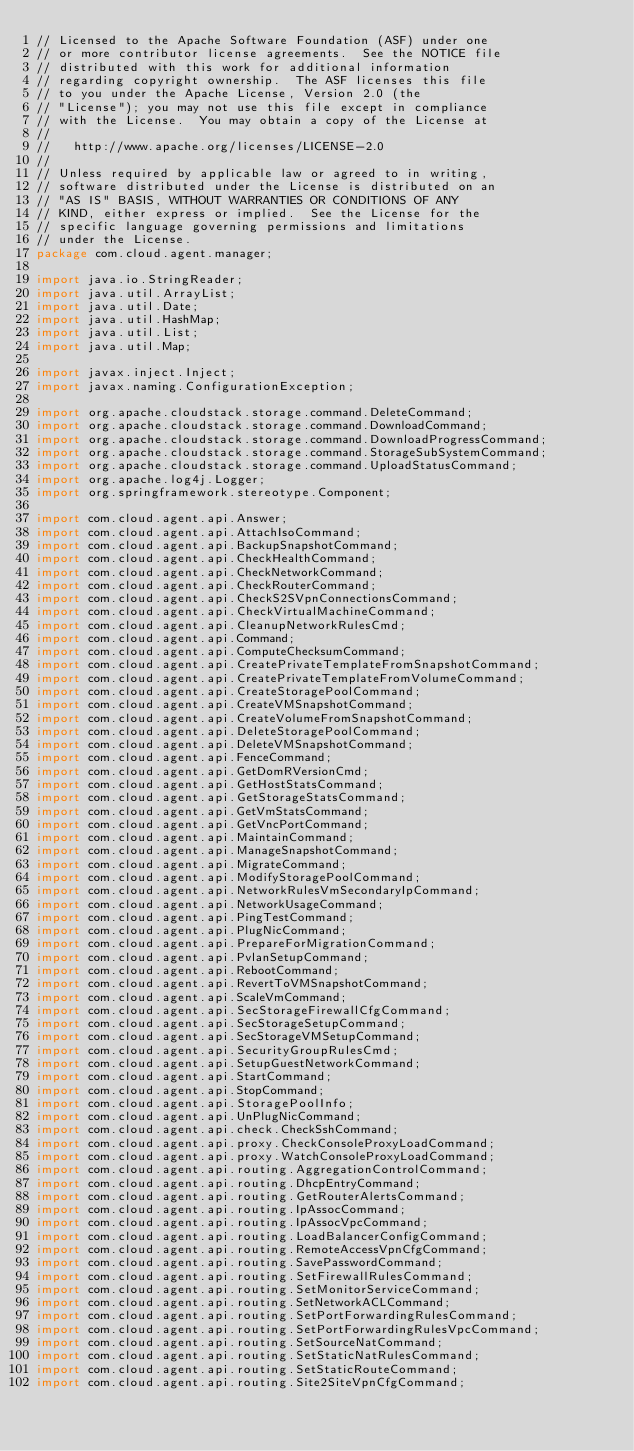<code> <loc_0><loc_0><loc_500><loc_500><_Java_>// Licensed to the Apache Software Foundation (ASF) under one
// or more contributor license agreements.  See the NOTICE file
// distributed with this work for additional information
// regarding copyright ownership.  The ASF licenses this file
// to you under the Apache License, Version 2.0 (the
// "License"); you may not use this file except in compliance
// with the License.  You may obtain a copy of the License at
//
//   http://www.apache.org/licenses/LICENSE-2.0
//
// Unless required by applicable law or agreed to in writing,
// software distributed under the License is distributed on an
// "AS IS" BASIS, WITHOUT WARRANTIES OR CONDITIONS OF ANY
// KIND, either express or implied.  See the License for the
// specific language governing permissions and limitations
// under the License.
package com.cloud.agent.manager;

import java.io.StringReader;
import java.util.ArrayList;
import java.util.Date;
import java.util.HashMap;
import java.util.List;
import java.util.Map;

import javax.inject.Inject;
import javax.naming.ConfigurationException;

import org.apache.cloudstack.storage.command.DeleteCommand;
import org.apache.cloudstack.storage.command.DownloadCommand;
import org.apache.cloudstack.storage.command.DownloadProgressCommand;
import org.apache.cloudstack.storage.command.StorageSubSystemCommand;
import org.apache.cloudstack.storage.command.UploadStatusCommand;
import org.apache.log4j.Logger;
import org.springframework.stereotype.Component;

import com.cloud.agent.api.Answer;
import com.cloud.agent.api.AttachIsoCommand;
import com.cloud.agent.api.BackupSnapshotCommand;
import com.cloud.agent.api.CheckHealthCommand;
import com.cloud.agent.api.CheckNetworkCommand;
import com.cloud.agent.api.CheckRouterCommand;
import com.cloud.agent.api.CheckS2SVpnConnectionsCommand;
import com.cloud.agent.api.CheckVirtualMachineCommand;
import com.cloud.agent.api.CleanupNetworkRulesCmd;
import com.cloud.agent.api.Command;
import com.cloud.agent.api.ComputeChecksumCommand;
import com.cloud.agent.api.CreatePrivateTemplateFromSnapshotCommand;
import com.cloud.agent.api.CreatePrivateTemplateFromVolumeCommand;
import com.cloud.agent.api.CreateStoragePoolCommand;
import com.cloud.agent.api.CreateVMSnapshotCommand;
import com.cloud.agent.api.CreateVolumeFromSnapshotCommand;
import com.cloud.agent.api.DeleteStoragePoolCommand;
import com.cloud.agent.api.DeleteVMSnapshotCommand;
import com.cloud.agent.api.FenceCommand;
import com.cloud.agent.api.GetDomRVersionCmd;
import com.cloud.agent.api.GetHostStatsCommand;
import com.cloud.agent.api.GetStorageStatsCommand;
import com.cloud.agent.api.GetVmStatsCommand;
import com.cloud.agent.api.GetVncPortCommand;
import com.cloud.agent.api.MaintainCommand;
import com.cloud.agent.api.ManageSnapshotCommand;
import com.cloud.agent.api.MigrateCommand;
import com.cloud.agent.api.ModifyStoragePoolCommand;
import com.cloud.agent.api.NetworkRulesVmSecondaryIpCommand;
import com.cloud.agent.api.NetworkUsageCommand;
import com.cloud.agent.api.PingTestCommand;
import com.cloud.agent.api.PlugNicCommand;
import com.cloud.agent.api.PrepareForMigrationCommand;
import com.cloud.agent.api.PvlanSetupCommand;
import com.cloud.agent.api.RebootCommand;
import com.cloud.agent.api.RevertToVMSnapshotCommand;
import com.cloud.agent.api.ScaleVmCommand;
import com.cloud.agent.api.SecStorageFirewallCfgCommand;
import com.cloud.agent.api.SecStorageSetupCommand;
import com.cloud.agent.api.SecStorageVMSetupCommand;
import com.cloud.agent.api.SecurityGroupRulesCmd;
import com.cloud.agent.api.SetupGuestNetworkCommand;
import com.cloud.agent.api.StartCommand;
import com.cloud.agent.api.StopCommand;
import com.cloud.agent.api.StoragePoolInfo;
import com.cloud.agent.api.UnPlugNicCommand;
import com.cloud.agent.api.check.CheckSshCommand;
import com.cloud.agent.api.proxy.CheckConsoleProxyLoadCommand;
import com.cloud.agent.api.proxy.WatchConsoleProxyLoadCommand;
import com.cloud.agent.api.routing.AggregationControlCommand;
import com.cloud.agent.api.routing.DhcpEntryCommand;
import com.cloud.agent.api.routing.GetRouterAlertsCommand;
import com.cloud.agent.api.routing.IpAssocCommand;
import com.cloud.agent.api.routing.IpAssocVpcCommand;
import com.cloud.agent.api.routing.LoadBalancerConfigCommand;
import com.cloud.agent.api.routing.RemoteAccessVpnCfgCommand;
import com.cloud.agent.api.routing.SavePasswordCommand;
import com.cloud.agent.api.routing.SetFirewallRulesCommand;
import com.cloud.agent.api.routing.SetMonitorServiceCommand;
import com.cloud.agent.api.routing.SetNetworkACLCommand;
import com.cloud.agent.api.routing.SetPortForwardingRulesCommand;
import com.cloud.agent.api.routing.SetPortForwardingRulesVpcCommand;
import com.cloud.agent.api.routing.SetSourceNatCommand;
import com.cloud.agent.api.routing.SetStaticNatRulesCommand;
import com.cloud.agent.api.routing.SetStaticRouteCommand;
import com.cloud.agent.api.routing.Site2SiteVpnCfgCommand;</code> 